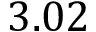Convert formula to latex. <formula><loc_0><loc_0><loc_500><loc_500>3 . 0 2</formula> 